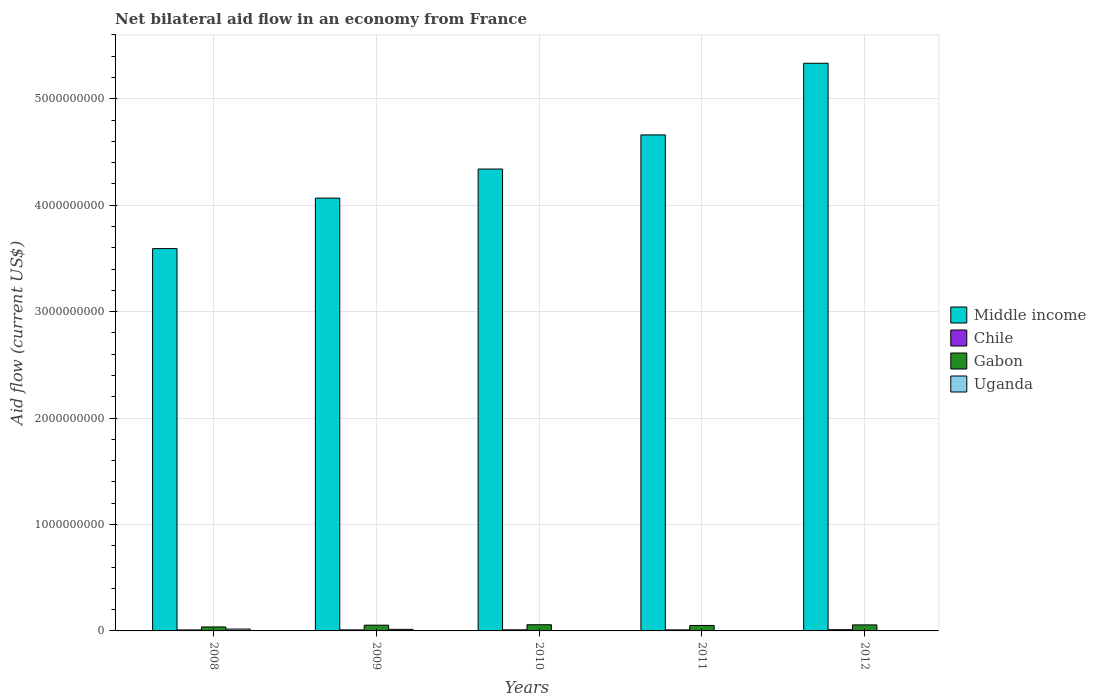How many different coloured bars are there?
Provide a short and direct response. 4. How many bars are there on the 5th tick from the left?
Provide a succinct answer. 3. What is the label of the 4th group of bars from the left?
Offer a very short reply. 2011. In how many cases, is the number of bars for a given year not equal to the number of legend labels?
Give a very brief answer. 1. What is the net bilateral aid flow in Chile in 2012?
Offer a very short reply. 1.15e+07. Across all years, what is the maximum net bilateral aid flow in Gabon?
Your answer should be compact. 5.81e+07. Across all years, what is the minimum net bilateral aid flow in Middle income?
Provide a succinct answer. 3.59e+09. What is the total net bilateral aid flow in Chile in the graph?
Your answer should be very brief. 5.00e+07. What is the difference between the net bilateral aid flow in Uganda in 2009 and that in 2011?
Provide a short and direct response. 1.40e+07. What is the difference between the net bilateral aid flow in Uganda in 2008 and the net bilateral aid flow in Chile in 2011?
Your answer should be very brief. 7.76e+06. What is the average net bilateral aid flow in Middle income per year?
Your response must be concise. 4.40e+09. In the year 2012, what is the difference between the net bilateral aid flow in Chile and net bilateral aid flow in Middle income?
Keep it short and to the point. -5.32e+09. In how many years, is the net bilateral aid flow in Gabon greater than 1800000000 US$?
Your answer should be very brief. 0. What is the ratio of the net bilateral aid flow in Uganda in 2010 to that in 2011?
Your response must be concise. 2.95. What is the difference between the highest and the second highest net bilateral aid flow in Middle income?
Your response must be concise. 6.73e+08. What is the difference between the highest and the lowest net bilateral aid flow in Gabon?
Ensure brevity in your answer.  2.07e+07. Is the sum of the net bilateral aid flow in Middle income in 2009 and 2010 greater than the maximum net bilateral aid flow in Chile across all years?
Your answer should be compact. Yes. How many bars are there?
Your answer should be very brief. 19. Are all the bars in the graph horizontal?
Provide a short and direct response. No. How many years are there in the graph?
Ensure brevity in your answer.  5. Are the values on the major ticks of Y-axis written in scientific E-notation?
Provide a short and direct response. No. Where does the legend appear in the graph?
Offer a very short reply. Center right. How many legend labels are there?
Give a very brief answer. 4. How are the legend labels stacked?
Your response must be concise. Vertical. What is the title of the graph?
Provide a succinct answer. Net bilateral aid flow in an economy from France. Does "Malawi" appear as one of the legend labels in the graph?
Keep it short and to the point. No. What is the label or title of the Y-axis?
Keep it short and to the point. Aid flow (current US$). What is the Aid flow (current US$) in Middle income in 2008?
Your response must be concise. 3.59e+09. What is the Aid flow (current US$) of Chile in 2008?
Offer a very short reply. 9.10e+06. What is the Aid flow (current US$) of Gabon in 2008?
Your answer should be very brief. 3.74e+07. What is the Aid flow (current US$) in Uganda in 2008?
Provide a succinct answer. 1.74e+07. What is the Aid flow (current US$) of Middle income in 2009?
Keep it short and to the point. 4.07e+09. What is the Aid flow (current US$) of Chile in 2009?
Provide a short and direct response. 9.60e+06. What is the Aid flow (current US$) in Gabon in 2009?
Ensure brevity in your answer.  5.40e+07. What is the Aid flow (current US$) in Uganda in 2009?
Provide a short and direct response. 1.46e+07. What is the Aid flow (current US$) of Middle income in 2010?
Offer a terse response. 4.34e+09. What is the Aid flow (current US$) in Chile in 2010?
Your answer should be very brief. 1.01e+07. What is the Aid flow (current US$) of Gabon in 2010?
Make the answer very short. 5.81e+07. What is the Aid flow (current US$) in Uganda in 2010?
Your answer should be compact. 1.77e+06. What is the Aid flow (current US$) in Middle income in 2011?
Ensure brevity in your answer.  4.66e+09. What is the Aid flow (current US$) in Chile in 2011?
Ensure brevity in your answer.  9.68e+06. What is the Aid flow (current US$) of Gabon in 2011?
Your answer should be compact. 5.14e+07. What is the Aid flow (current US$) of Uganda in 2011?
Offer a terse response. 6.00e+05. What is the Aid flow (current US$) in Middle income in 2012?
Your answer should be compact. 5.33e+09. What is the Aid flow (current US$) of Chile in 2012?
Your answer should be very brief. 1.15e+07. What is the Aid flow (current US$) in Gabon in 2012?
Your answer should be compact. 5.66e+07. What is the Aid flow (current US$) of Uganda in 2012?
Offer a terse response. 0. Across all years, what is the maximum Aid flow (current US$) of Middle income?
Give a very brief answer. 5.33e+09. Across all years, what is the maximum Aid flow (current US$) in Chile?
Ensure brevity in your answer.  1.15e+07. Across all years, what is the maximum Aid flow (current US$) of Gabon?
Provide a short and direct response. 5.81e+07. Across all years, what is the maximum Aid flow (current US$) in Uganda?
Provide a succinct answer. 1.74e+07. Across all years, what is the minimum Aid flow (current US$) in Middle income?
Offer a very short reply. 3.59e+09. Across all years, what is the minimum Aid flow (current US$) of Chile?
Your answer should be compact. 9.10e+06. Across all years, what is the minimum Aid flow (current US$) in Gabon?
Offer a terse response. 3.74e+07. What is the total Aid flow (current US$) of Middle income in the graph?
Your answer should be compact. 2.20e+1. What is the total Aid flow (current US$) of Chile in the graph?
Make the answer very short. 5.00e+07. What is the total Aid flow (current US$) of Gabon in the graph?
Your response must be concise. 2.57e+08. What is the total Aid flow (current US$) in Uganda in the graph?
Ensure brevity in your answer.  3.44e+07. What is the difference between the Aid flow (current US$) in Middle income in 2008 and that in 2009?
Ensure brevity in your answer.  -4.75e+08. What is the difference between the Aid flow (current US$) in Chile in 2008 and that in 2009?
Give a very brief answer. -5.00e+05. What is the difference between the Aid flow (current US$) in Gabon in 2008 and that in 2009?
Your response must be concise. -1.65e+07. What is the difference between the Aid flow (current US$) in Uganda in 2008 and that in 2009?
Your answer should be compact. 2.87e+06. What is the difference between the Aid flow (current US$) in Middle income in 2008 and that in 2010?
Ensure brevity in your answer.  -7.48e+08. What is the difference between the Aid flow (current US$) in Chile in 2008 and that in 2010?
Give a very brief answer. -1.03e+06. What is the difference between the Aid flow (current US$) in Gabon in 2008 and that in 2010?
Make the answer very short. -2.07e+07. What is the difference between the Aid flow (current US$) in Uganda in 2008 and that in 2010?
Keep it short and to the point. 1.57e+07. What is the difference between the Aid flow (current US$) in Middle income in 2008 and that in 2011?
Provide a succinct answer. -1.07e+09. What is the difference between the Aid flow (current US$) in Chile in 2008 and that in 2011?
Make the answer very short. -5.80e+05. What is the difference between the Aid flow (current US$) in Gabon in 2008 and that in 2011?
Keep it short and to the point. -1.40e+07. What is the difference between the Aid flow (current US$) in Uganda in 2008 and that in 2011?
Offer a very short reply. 1.68e+07. What is the difference between the Aid flow (current US$) in Middle income in 2008 and that in 2012?
Offer a very short reply. -1.74e+09. What is the difference between the Aid flow (current US$) of Chile in 2008 and that in 2012?
Make the answer very short. -2.40e+06. What is the difference between the Aid flow (current US$) of Gabon in 2008 and that in 2012?
Your answer should be compact. -1.91e+07. What is the difference between the Aid flow (current US$) in Middle income in 2009 and that in 2010?
Offer a terse response. -2.73e+08. What is the difference between the Aid flow (current US$) of Chile in 2009 and that in 2010?
Provide a succinct answer. -5.30e+05. What is the difference between the Aid flow (current US$) of Gabon in 2009 and that in 2010?
Provide a succinct answer. -4.18e+06. What is the difference between the Aid flow (current US$) of Uganda in 2009 and that in 2010?
Keep it short and to the point. 1.28e+07. What is the difference between the Aid flow (current US$) of Middle income in 2009 and that in 2011?
Your answer should be compact. -5.94e+08. What is the difference between the Aid flow (current US$) of Chile in 2009 and that in 2011?
Offer a terse response. -8.00e+04. What is the difference between the Aid flow (current US$) in Gabon in 2009 and that in 2011?
Provide a short and direct response. 2.56e+06. What is the difference between the Aid flow (current US$) in Uganda in 2009 and that in 2011?
Keep it short and to the point. 1.40e+07. What is the difference between the Aid flow (current US$) of Middle income in 2009 and that in 2012?
Ensure brevity in your answer.  -1.27e+09. What is the difference between the Aid flow (current US$) of Chile in 2009 and that in 2012?
Make the answer very short. -1.90e+06. What is the difference between the Aid flow (current US$) in Gabon in 2009 and that in 2012?
Your response must be concise. -2.61e+06. What is the difference between the Aid flow (current US$) of Middle income in 2010 and that in 2011?
Offer a very short reply. -3.21e+08. What is the difference between the Aid flow (current US$) of Chile in 2010 and that in 2011?
Your answer should be compact. 4.50e+05. What is the difference between the Aid flow (current US$) of Gabon in 2010 and that in 2011?
Make the answer very short. 6.74e+06. What is the difference between the Aid flow (current US$) in Uganda in 2010 and that in 2011?
Give a very brief answer. 1.17e+06. What is the difference between the Aid flow (current US$) of Middle income in 2010 and that in 2012?
Make the answer very short. -9.94e+08. What is the difference between the Aid flow (current US$) of Chile in 2010 and that in 2012?
Make the answer very short. -1.37e+06. What is the difference between the Aid flow (current US$) in Gabon in 2010 and that in 2012?
Give a very brief answer. 1.57e+06. What is the difference between the Aid flow (current US$) in Middle income in 2011 and that in 2012?
Offer a very short reply. -6.73e+08. What is the difference between the Aid flow (current US$) of Chile in 2011 and that in 2012?
Your answer should be compact. -1.82e+06. What is the difference between the Aid flow (current US$) in Gabon in 2011 and that in 2012?
Offer a very short reply. -5.17e+06. What is the difference between the Aid flow (current US$) in Middle income in 2008 and the Aid flow (current US$) in Chile in 2009?
Your response must be concise. 3.58e+09. What is the difference between the Aid flow (current US$) of Middle income in 2008 and the Aid flow (current US$) of Gabon in 2009?
Offer a very short reply. 3.54e+09. What is the difference between the Aid flow (current US$) of Middle income in 2008 and the Aid flow (current US$) of Uganda in 2009?
Your response must be concise. 3.58e+09. What is the difference between the Aid flow (current US$) in Chile in 2008 and the Aid flow (current US$) in Gabon in 2009?
Offer a terse response. -4.48e+07. What is the difference between the Aid flow (current US$) in Chile in 2008 and the Aid flow (current US$) in Uganda in 2009?
Offer a very short reply. -5.47e+06. What is the difference between the Aid flow (current US$) in Gabon in 2008 and the Aid flow (current US$) in Uganda in 2009?
Provide a short and direct response. 2.28e+07. What is the difference between the Aid flow (current US$) of Middle income in 2008 and the Aid flow (current US$) of Chile in 2010?
Make the answer very short. 3.58e+09. What is the difference between the Aid flow (current US$) of Middle income in 2008 and the Aid flow (current US$) of Gabon in 2010?
Provide a short and direct response. 3.53e+09. What is the difference between the Aid flow (current US$) in Middle income in 2008 and the Aid flow (current US$) in Uganda in 2010?
Ensure brevity in your answer.  3.59e+09. What is the difference between the Aid flow (current US$) of Chile in 2008 and the Aid flow (current US$) of Gabon in 2010?
Keep it short and to the point. -4.90e+07. What is the difference between the Aid flow (current US$) of Chile in 2008 and the Aid flow (current US$) of Uganda in 2010?
Keep it short and to the point. 7.33e+06. What is the difference between the Aid flow (current US$) of Gabon in 2008 and the Aid flow (current US$) of Uganda in 2010?
Give a very brief answer. 3.56e+07. What is the difference between the Aid flow (current US$) in Middle income in 2008 and the Aid flow (current US$) in Chile in 2011?
Provide a succinct answer. 3.58e+09. What is the difference between the Aid flow (current US$) in Middle income in 2008 and the Aid flow (current US$) in Gabon in 2011?
Provide a short and direct response. 3.54e+09. What is the difference between the Aid flow (current US$) in Middle income in 2008 and the Aid flow (current US$) in Uganda in 2011?
Your answer should be compact. 3.59e+09. What is the difference between the Aid flow (current US$) of Chile in 2008 and the Aid flow (current US$) of Gabon in 2011?
Provide a short and direct response. -4.23e+07. What is the difference between the Aid flow (current US$) in Chile in 2008 and the Aid flow (current US$) in Uganda in 2011?
Ensure brevity in your answer.  8.50e+06. What is the difference between the Aid flow (current US$) of Gabon in 2008 and the Aid flow (current US$) of Uganda in 2011?
Your answer should be compact. 3.68e+07. What is the difference between the Aid flow (current US$) of Middle income in 2008 and the Aid flow (current US$) of Chile in 2012?
Offer a terse response. 3.58e+09. What is the difference between the Aid flow (current US$) of Middle income in 2008 and the Aid flow (current US$) of Gabon in 2012?
Provide a short and direct response. 3.54e+09. What is the difference between the Aid flow (current US$) of Chile in 2008 and the Aid flow (current US$) of Gabon in 2012?
Provide a short and direct response. -4.75e+07. What is the difference between the Aid flow (current US$) of Middle income in 2009 and the Aid flow (current US$) of Chile in 2010?
Ensure brevity in your answer.  4.06e+09. What is the difference between the Aid flow (current US$) of Middle income in 2009 and the Aid flow (current US$) of Gabon in 2010?
Offer a terse response. 4.01e+09. What is the difference between the Aid flow (current US$) of Middle income in 2009 and the Aid flow (current US$) of Uganda in 2010?
Ensure brevity in your answer.  4.06e+09. What is the difference between the Aid flow (current US$) of Chile in 2009 and the Aid flow (current US$) of Gabon in 2010?
Your answer should be compact. -4.85e+07. What is the difference between the Aid flow (current US$) in Chile in 2009 and the Aid flow (current US$) in Uganda in 2010?
Your response must be concise. 7.83e+06. What is the difference between the Aid flow (current US$) in Gabon in 2009 and the Aid flow (current US$) in Uganda in 2010?
Ensure brevity in your answer.  5.22e+07. What is the difference between the Aid flow (current US$) in Middle income in 2009 and the Aid flow (current US$) in Chile in 2011?
Give a very brief answer. 4.06e+09. What is the difference between the Aid flow (current US$) in Middle income in 2009 and the Aid flow (current US$) in Gabon in 2011?
Provide a short and direct response. 4.02e+09. What is the difference between the Aid flow (current US$) of Middle income in 2009 and the Aid flow (current US$) of Uganda in 2011?
Provide a short and direct response. 4.07e+09. What is the difference between the Aid flow (current US$) in Chile in 2009 and the Aid flow (current US$) in Gabon in 2011?
Provide a succinct answer. -4.18e+07. What is the difference between the Aid flow (current US$) in Chile in 2009 and the Aid flow (current US$) in Uganda in 2011?
Your answer should be very brief. 9.00e+06. What is the difference between the Aid flow (current US$) of Gabon in 2009 and the Aid flow (current US$) of Uganda in 2011?
Give a very brief answer. 5.34e+07. What is the difference between the Aid flow (current US$) in Middle income in 2009 and the Aid flow (current US$) in Chile in 2012?
Give a very brief answer. 4.06e+09. What is the difference between the Aid flow (current US$) in Middle income in 2009 and the Aid flow (current US$) in Gabon in 2012?
Offer a terse response. 4.01e+09. What is the difference between the Aid flow (current US$) in Chile in 2009 and the Aid flow (current US$) in Gabon in 2012?
Your response must be concise. -4.70e+07. What is the difference between the Aid flow (current US$) of Middle income in 2010 and the Aid flow (current US$) of Chile in 2011?
Make the answer very short. 4.33e+09. What is the difference between the Aid flow (current US$) of Middle income in 2010 and the Aid flow (current US$) of Gabon in 2011?
Offer a terse response. 4.29e+09. What is the difference between the Aid flow (current US$) in Middle income in 2010 and the Aid flow (current US$) in Uganda in 2011?
Offer a very short reply. 4.34e+09. What is the difference between the Aid flow (current US$) in Chile in 2010 and the Aid flow (current US$) in Gabon in 2011?
Your answer should be very brief. -4.13e+07. What is the difference between the Aid flow (current US$) in Chile in 2010 and the Aid flow (current US$) in Uganda in 2011?
Give a very brief answer. 9.53e+06. What is the difference between the Aid flow (current US$) in Gabon in 2010 and the Aid flow (current US$) in Uganda in 2011?
Your response must be concise. 5.75e+07. What is the difference between the Aid flow (current US$) of Middle income in 2010 and the Aid flow (current US$) of Chile in 2012?
Keep it short and to the point. 4.33e+09. What is the difference between the Aid flow (current US$) of Middle income in 2010 and the Aid flow (current US$) of Gabon in 2012?
Offer a very short reply. 4.28e+09. What is the difference between the Aid flow (current US$) of Chile in 2010 and the Aid flow (current US$) of Gabon in 2012?
Your response must be concise. -4.64e+07. What is the difference between the Aid flow (current US$) in Middle income in 2011 and the Aid flow (current US$) in Chile in 2012?
Provide a short and direct response. 4.65e+09. What is the difference between the Aid flow (current US$) of Middle income in 2011 and the Aid flow (current US$) of Gabon in 2012?
Keep it short and to the point. 4.60e+09. What is the difference between the Aid flow (current US$) of Chile in 2011 and the Aid flow (current US$) of Gabon in 2012?
Offer a terse response. -4.69e+07. What is the average Aid flow (current US$) of Middle income per year?
Your answer should be compact. 4.40e+09. What is the average Aid flow (current US$) in Chile per year?
Your answer should be compact. 1.00e+07. What is the average Aid flow (current US$) of Gabon per year?
Offer a terse response. 5.15e+07. What is the average Aid flow (current US$) of Uganda per year?
Your answer should be very brief. 6.88e+06. In the year 2008, what is the difference between the Aid flow (current US$) in Middle income and Aid flow (current US$) in Chile?
Provide a succinct answer. 3.58e+09. In the year 2008, what is the difference between the Aid flow (current US$) of Middle income and Aid flow (current US$) of Gabon?
Your answer should be compact. 3.55e+09. In the year 2008, what is the difference between the Aid flow (current US$) of Middle income and Aid flow (current US$) of Uganda?
Ensure brevity in your answer.  3.57e+09. In the year 2008, what is the difference between the Aid flow (current US$) in Chile and Aid flow (current US$) in Gabon?
Offer a very short reply. -2.83e+07. In the year 2008, what is the difference between the Aid flow (current US$) of Chile and Aid flow (current US$) of Uganda?
Keep it short and to the point. -8.34e+06. In the year 2008, what is the difference between the Aid flow (current US$) in Gabon and Aid flow (current US$) in Uganda?
Ensure brevity in your answer.  2.00e+07. In the year 2009, what is the difference between the Aid flow (current US$) of Middle income and Aid flow (current US$) of Chile?
Provide a succinct answer. 4.06e+09. In the year 2009, what is the difference between the Aid flow (current US$) of Middle income and Aid flow (current US$) of Gabon?
Give a very brief answer. 4.01e+09. In the year 2009, what is the difference between the Aid flow (current US$) in Middle income and Aid flow (current US$) in Uganda?
Ensure brevity in your answer.  4.05e+09. In the year 2009, what is the difference between the Aid flow (current US$) in Chile and Aid flow (current US$) in Gabon?
Your answer should be very brief. -4.44e+07. In the year 2009, what is the difference between the Aid flow (current US$) of Chile and Aid flow (current US$) of Uganda?
Provide a short and direct response. -4.97e+06. In the year 2009, what is the difference between the Aid flow (current US$) in Gabon and Aid flow (current US$) in Uganda?
Your response must be concise. 3.94e+07. In the year 2010, what is the difference between the Aid flow (current US$) in Middle income and Aid flow (current US$) in Chile?
Keep it short and to the point. 4.33e+09. In the year 2010, what is the difference between the Aid flow (current US$) of Middle income and Aid flow (current US$) of Gabon?
Provide a short and direct response. 4.28e+09. In the year 2010, what is the difference between the Aid flow (current US$) of Middle income and Aid flow (current US$) of Uganda?
Ensure brevity in your answer.  4.34e+09. In the year 2010, what is the difference between the Aid flow (current US$) of Chile and Aid flow (current US$) of Gabon?
Make the answer very short. -4.80e+07. In the year 2010, what is the difference between the Aid flow (current US$) in Chile and Aid flow (current US$) in Uganda?
Your answer should be compact. 8.36e+06. In the year 2010, what is the difference between the Aid flow (current US$) in Gabon and Aid flow (current US$) in Uganda?
Make the answer very short. 5.64e+07. In the year 2011, what is the difference between the Aid flow (current US$) of Middle income and Aid flow (current US$) of Chile?
Your response must be concise. 4.65e+09. In the year 2011, what is the difference between the Aid flow (current US$) of Middle income and Aid flow (current US$) of Gabon?
Offer a terse response. 4.61e+09. In the year 2011, what is the difference between the Aid flow (current US$) of Middle income and Aid flow (current US$) of Uganda?
Provide a short and direct response. 4.66e+09. In the year 2011, what is the difference between the Aid flow (current US$) of Chile and Aid flow (current US$) of Gabon?
Give a very brief answer. -4.17e+07. In the year 2011, what is the difference between the Aid flow (current US$) in Chile and Aid flow (current US$) in Uganda?
Your response must be concise. 9.08e+06. In the year 2011, what is the difference between the Aid flow (current US$) of Gabon and Aid flow (current US$) of Uganda?
Offer a terse response. 5.08e+07. In the year 2012, what is the difference between the Aid flow (current US$) in Middle income and Aid flow (current US$) in Chile?
Your answer should be very brief. 5.32e+09. In the year 2012, what is the difference between the Aid flow (current US$) of Middle income and Aid flow (current US$) of Gabon?
Your response must be concise. 5.28e+09. In the year 2012, what is the difference between the Aid flow (current US$) of Chile and Aid flow (current US$) of Gabon?
Make the answer very short. -4.51e+07. What is the ratio of the Aid flow (current US$) in Middle income in 2008 to that in 2009?
Provide a short and direct response. 0.88. What is the ratio of the Aid flow (current US$) in Chile in 2008 to that in 2009?
Ensure brevity in your answer.  0.95. What is the ratio of the Aid flow (current US$) in Gabon in 2008 to that in 2009?
Your response must be concise. 0.69. What is the ratio of the Aid flow (current US$) in Uganda in 2008 to that in 2009?
Provide a succinct answer. 1.2. What is the ratio of the Aid flow (current US$) of Middle income in 2008 to that in 2010?
Your answer should be compact. 0.83. What is the ratio of the Aid flow (current US$) of Chile in 2008 to that in 2010?
Make the answer very short. 0.9. What is the ratio of the Aid flow (current US$) of Gabon in 2008 to that in 2010?
Your answer should be very brief. 0.64. What is the ratio of the Aid flow (current US$) of Uganda in 2008 to that in 2010?
Offer a terse response. 9.85. What is the ratio of the Aid flow (current US$) in Middle income in 2008 to that in 2011?
Ensure brevity in your answer.  0.77. What is the ratio of the Aid flow (current US$) in Chile in 2008 to that in 2011?
Your answer should be compact. 0.94. What is the ratio of the Aid flow (current US$) of Gabon in 2008 to that in 2011?
Ensure brevity in your answer.  0.73. What is the ratio of the Aid flow (current US$) in Uganda in 2008 to that in 2011?
Offer a very short reply. 29.07. What is the ratio of the Aid flow (current US$) in Middle income in 2008 to that in 2012?
Offer a very short reply. 0.67. What is the ratio of the Aid flow (current US$) of Chile in 2008 to that in 2012?
Your answer should be very brief. 0.79. What is the ratio of the Aid flow (current US$) in Gabon in 2008 to that in 2012?
Ensure brevity in your answer.  0.66. What is the ratio of the Aid flow (current US$) of Middle income in 2009 to that in 2010?
Keep it short and to the point. 0.94. What is the ratio of the Aid flow (current US$) of Chile in 2009 to that in 2010?
Provide a short and direct response. 0.95. What is the ratio of the Aid flow (current US$) in Gabon in 2009 to that in 2010?
Give a very brief answer. 0.93. What is the ratio of the Aid flow (current US$) of Uganda in 2009 to that in 2010?
Your answer should be compact. 8.23. What is the ratio of the Aid flow (current US$) in Middle income in 2009 to that in 2011?
Offer a terse response. 0.87. What is the ratio of the Aid flow (current US$) in Gabon in 2009 to that in 2011?
Your answer should be very brief. 1.05. What is the ratio of the Aid flow (current US$) of Uganda in 2009 to that in 2011?
Your answer should be very brief. 24.28. What is the ratio of the Aid flow (current US$) in Middle income in 2009 to that in 2012?
Your response must be concise. 0.76. What is the ratio of the Aid flow (current US$) in Chile in 2009 to that in 2012?
Your answer should be compact. 0.83. What is the ratio of the Aid flow (current US$) in Gabon in 2009 to that in 2012?
Your response must be concise. 0.95. What is the ratio of the Aid flow (current US$) in Middle income in 2010 to that in 2011?
Your answer should be compact. 0.93. What is the ratio of the Aid flow (current US$) of Chile in 2010 to that in 2011?
Ensure brevity in your answer.  1.05. What is the ratio of the Aid flow (current US$) in Gabon in 2010 to that in 2011?
Keep it short and to the point. 1.13. What is the ratio of the Aid flow (current US$) in Uganda in 2010 to that in 2011?
Provide a short and direct response. 2.95. What is the ratio of the Aid flow (current US$) of Middle income in 2010 to that in 2012?
Keep it short and to the point. 0.81. What is the ratio of the Aid flow (current US$) in Chile in 2010 to that in 2012?
Provide a succinct answer. 0.88. What is the ratio of the Aid flow (current US$) in Gabon in 2010 to that in 2012?
Your response must be concise. 1.03. What is the ratio of the Aid flow (current US$) of Middle income in 2011 to that in 2012?
Keep it short and to the point. 0.87. What is the ratio of the Aid flow (current US$) in Chile in 2011 to that in 2012?
Your response must be concise. 0.84. What is the ratio of the Aid flow (current US$) in Gabon in 2011 to that in 2012?
Provide a succinct answer. 0.91. What is the difference between the highest and the second highest Aid flow (current US$) of Middle income?
Offer a terse response. 6.73e+08. What is the difference between the highest and the second highest Aid flow (current US$) in Chile?
Make the answer very short. 1.37e+06. What is the difference between the highest and the second highest Aid flow (current US$) in Gabon?
Give a very brief answer. 1.57e+06. What is the difference between the highest and the second highest Aid flow (current US$) of Uganda?
Provide a short and direct response. 2.87e+06. What is the difference between the highest and the lowest Aid flow (current US$) of Middle income?
Give a very brief answer. 1.74e+09. What is the difference between the highest and the lowest Aid flow (current US$) in Chile?
Give a very brief answer. 2.40e+06. What is the difference between the highest and the lowest Aid flow (current US$) of Gabon?
Provide a succinct answer. 2.07e+07. What is the difference between the highest and the lowest Aid flow (current US$) in Uganda?
Provide a short and direct response. 1.74e+07. 